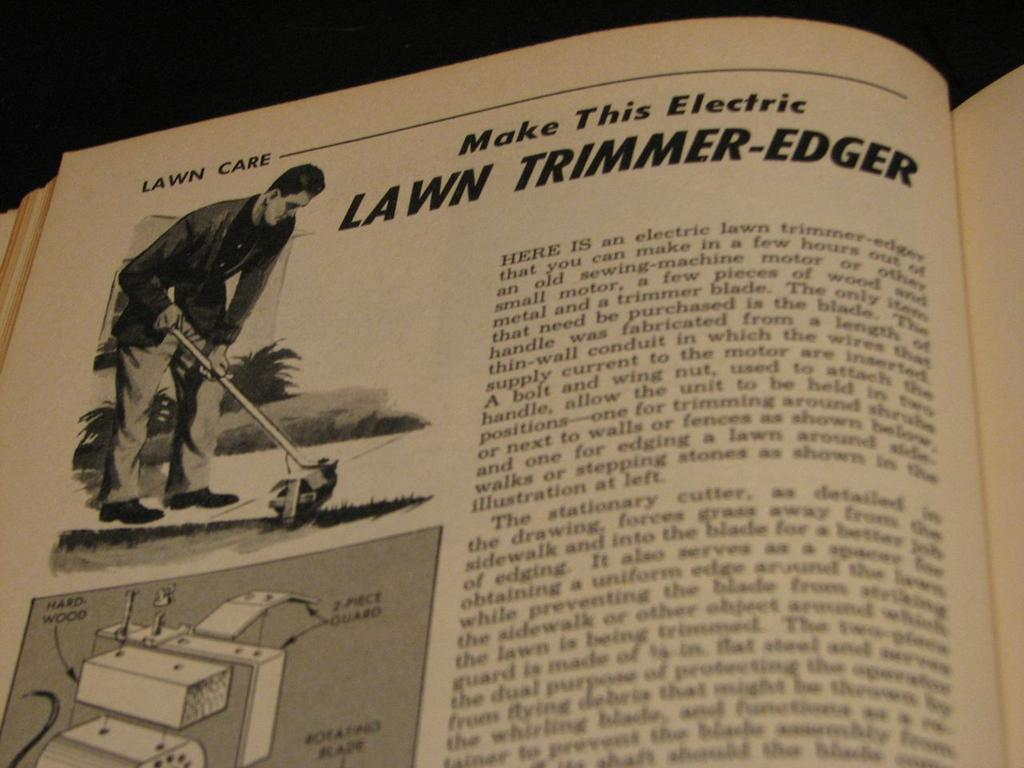Provide a one-sentence caption for the provided image. An illustration of a man shows him using an electric lawn trimmer-edger. 